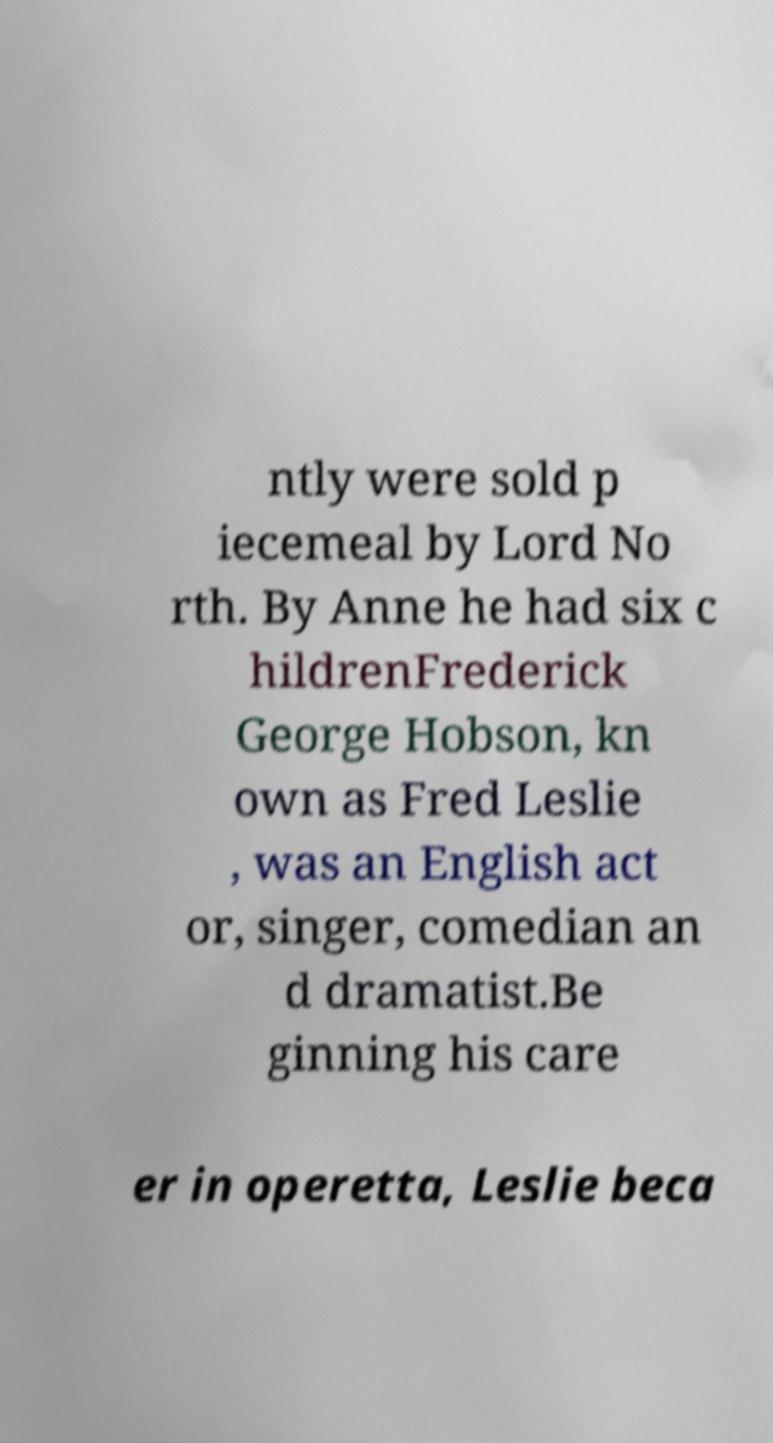What messages or text are displayed in this image? I need them in a readable, typed format. ntly were sold p iecemeal by Lord No rth. By Anne he had six c hildrenFrederick George Hobson, kn own as Fred Leslie , was an English act or, singer, comedian an d dramatist.Be ginning his care er in operetta, Leslie beca 